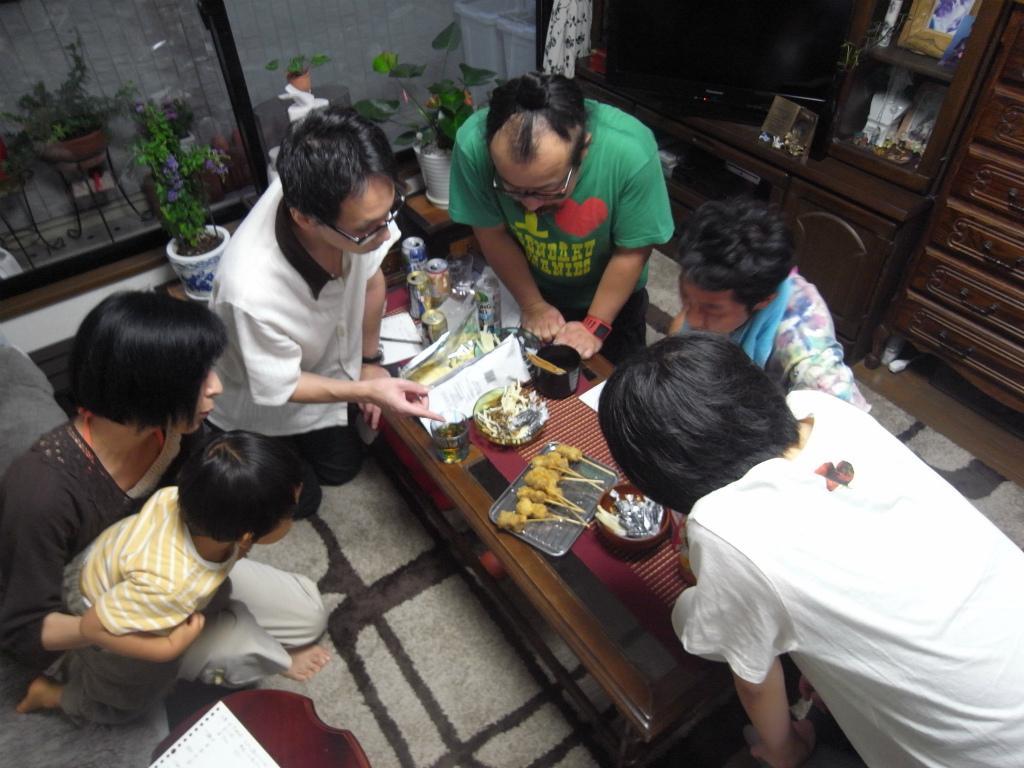Could you give a brief overview of what you see in this image? In this image there are group of people sitting on the ground. To the left there is woman holding a kid. Besides her there is a man, he is wearing a white shirt and black trousers. Towards the right there is another person wearing a white shirt, besides her there is a person wearing colored dress. In the middle there is a person, he is wearing a green t shirt. Among them there is a table, on the table there are cans, food, tray, glasses. In the background there are some plants, desk and cupboards. 